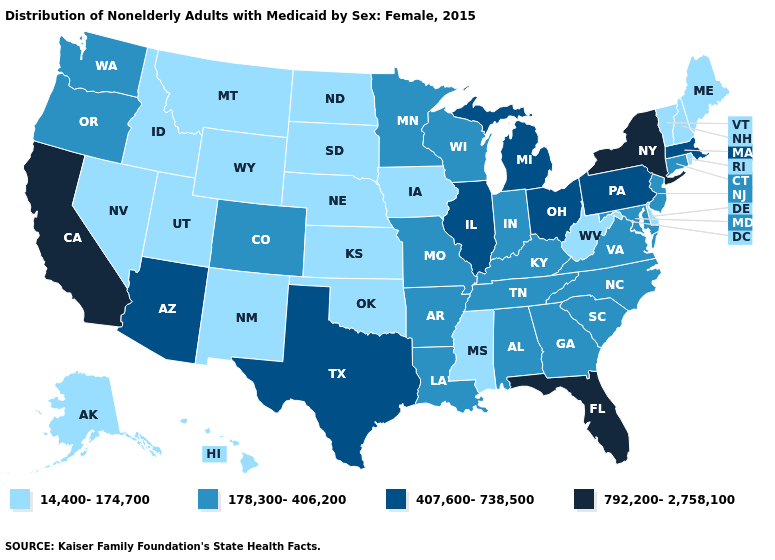Is the legend a continuous bar?
Write a very short answer. No. Does Florida have the same value as Ohio?
Keep it brief. No. What is the value of North Dakota?
Write a very short answer. 14,400-174,700. Name the states that have a value in the range 792,200-2,758,100?
Concise answer only. California, Florida, New York. Which states have the lowest value in the USA?
Be succinct. Alaska, Delaware, Hawaii, Idaho, Iowa, Kansas, Maine, Mississippi, Montana, Nebraska, Nevada, New Hampshire, New Mexico, North Dakota, Oklahoma, Rhode Island, South Dakota, Utah, Vermont, West Virginia, Wyoming. Name the states that have a value in the range 178,300-406,200?
Quick response, please. Alabama, Arkansas, Colorado, Connecticut, Georgia, Indiana, Kentucky, Louisiana, Maryland, Minnesota, Missouri, New Jersey, North Carolina, Oregon, South Carolina, Tennessee, Virginia, Washington, Wisconsin. Among the states that border Massachusetts , does Vermont have the lowest value?
Be succinct. Yes. Among the states that border West Virginia , which have the lowest value?
Concise answer only. Kentucky, Maryland, Virginia. Name the states that have a value in the range 178,300-406,200?
Be succinct. Alabama, Arkansas, Colorado, Connecticut, Georgia, Indiana, Kentucky, Louisiana, Maryland, Minnesota, Missouri, New Jersey, North Carolina, Oregon, South Carolina, Tennessee, Virginia, Washington, Wisconsin. Name the states that have a value in the range 407,600-738,500?
Give a very brief answer. Arizona, Illinois, Massachusetts, Michigan, Ohio, Pennsylvania, Texas. How many symbols are there in the legend?
Keep it brief. 4. Does the map have missing data?
Give a very brief answer. No. What is the value of Montana?
Answer briefly. 14,400-174,700. Which states have the lowest value in the MidWest?
Be succinct. Iowa, Kansas, Nebraska, North Dakota, South Dakota. Is the legend a continuous bar?
Concise answer only. No. 